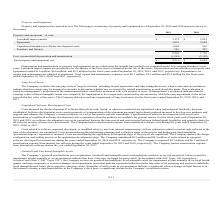According to Mitek Systems's financial document, What segment do expenditures for repairs and maintenance belong to? According to the financial document, operations. The relevant text states: "itures for repairs and maintenance are charged to operations. Total repairs and maintenance expenses were $0.1 million, $0.1 million and $0.2 million for the fi..." Also, What are the total depreciation and amortization of property and equipment for the fiscal year 2018 and 2019, respectively? The document shows two values: $0.6 million and $1.4 million. From the document: "on of property and equipment totaled $1.4 million, $0.6 million, and $0.3 million for the fiscal years ended September 30, 2019, 2018, and 2017, respe..." Also, What does the table provide for us? a summary of property and equipment as of September 30, 2019 and 2018. The document states: "d equipment are carried at cost. The following is a summary of property and equipment as of September 30, 2019 and 2018 (amounts shown in..." Also, can you calculate: What is the average of total repairs and maintenance expenses from 2017 to 2019? To answer this question, I need to perform calculations using the financial data. The calculation is: (0.1+0.1+0.2)/3 , which equals 0.13 (in millions). This is based on the information: "nce expenses were $0.1 million, $0.1 million and $0.2 million for the fiscal years ended September 30, 2019, 2018, and 2017, respectively. ons. Total repairs and maintenance expenses were $0.1 million..." The key data points involved are: 0.2. Also, can you calculate: What is the percentage change of net total property and equipment from 2018 to 2019? To answer this question, I need to perform calculations using the financial data. The calculation is: (4,231-4,665)/4,665 , which equals -9.3 (percentage). This is based on the information: "Total property and equipment, net $ 4,231 $ 4,665 Total property and equipment, net $ 4,231 $ 4,665..." The key data points involved are: 4,231, 4,665. Also, can you calculate: What is the proportion of the total value of leasehold improvements and equipment over the total value of property and equipment at cost in 2019? To answer this question, I need to perform calculations using the financial data. The calculation is: (3,575+3,041)/8,230 , which equals 0.8. This is based on the information: "8,230 7,770 Equipment 3,041 2,604 Leasehold improvements $ 3,575 $ 3,825..." The key data points involved are: 3,041, 3,575, 8,230. 